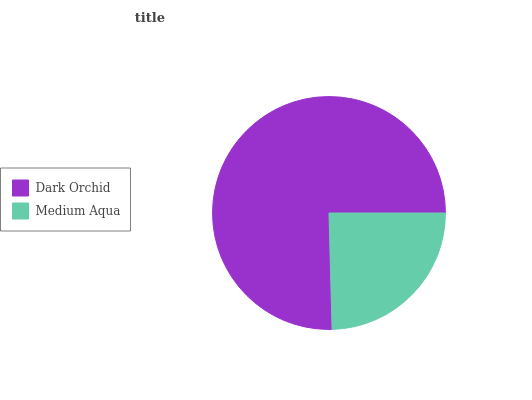Is Medium Aqua the minimum?
Answer yes or no. Yes. Is Dark Orchid the maximum?
Answer yes or no. Yes. Is Medium Aqua the maximum?
Answer yes or no. No. Is Dark Orchid greater than Medium Aqua?
Answer yes or no. Yes. Is Medium Aqua less than Dark Orchid?
Answer yes or no. Yes. Is Medium Aqua greater than Dark Orchid?
Answer yes or no. No. Is Dark Orchid less than Medium Aqua?
Answer yes or no. No. Is Dark Orchid the high median?
Answer yes or no. Yes. Is Medium Aqua the low median?
Answer yes or no. Yes. Is Medium Aqua the high median?
Answer yes or no. No. Is Dark Orchid the low median?
Answer yes or no. No. 